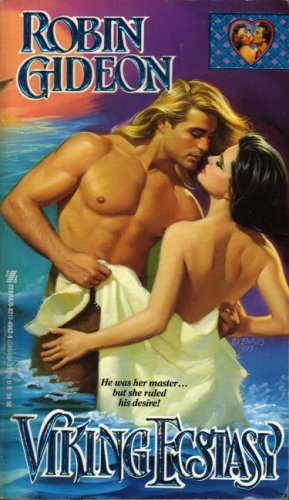What era or historical period does this book depict? The book appears to depict scenes from the Viking age, as evidenced by the title 'Viking Ecstasy' and the historical attire of the characters. 